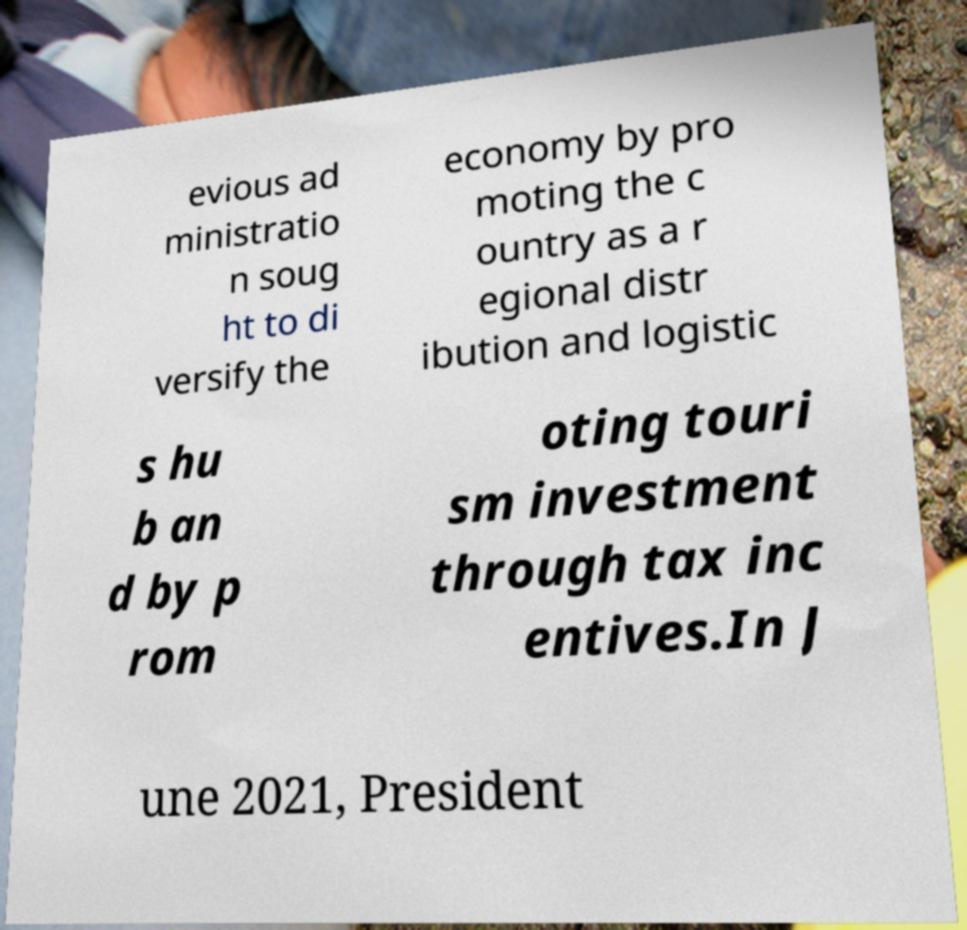Can you accurately transcribe the text from the provided image for me? evious ad ministratio n soug ht to di versify the economy by pro moting the c ountry as a r egional distr ibution and logistic s hu b an d by p rom oting touri sm investment through tax inc entives.In J une 2021, President 